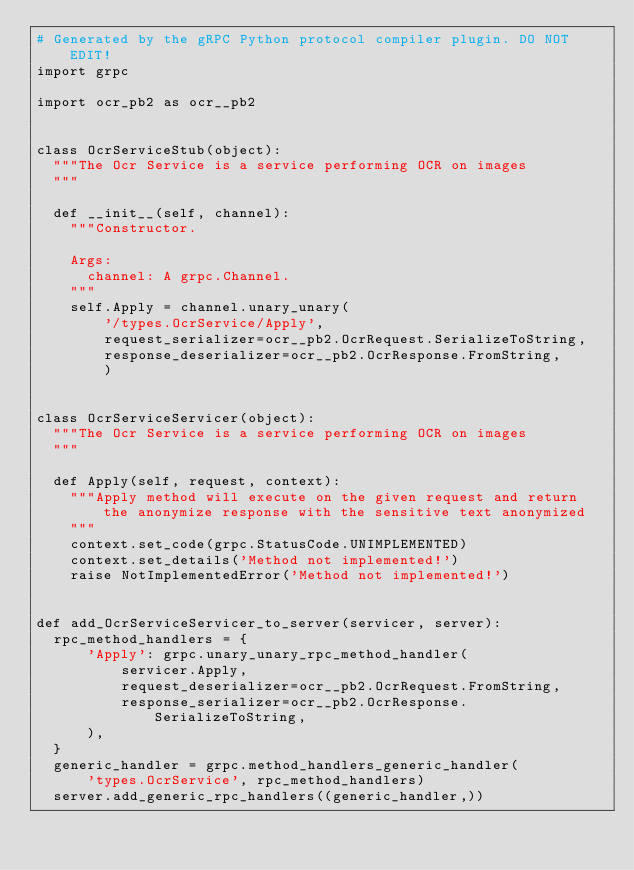Convert code to text. <code><loc_0><loc_0><loc_500><loc_500><_Python_># Generated by the gRPC Python protocol compiler plugin. DO NOT EDIT!
import grpc

import ocr_pb2 as ocr__pb2


class OcrServiceStub(object):
  """The Ocr Service is a service performing OCR on images
  """

  def __init__(self, channel):
    """Constructor.

    Args:
      channel: A grpc.Channel.
    """
    self.Apply = channel.unary_unary(
        '/types.OcrService/Apply',
        request_serializer=ocr__pb2.OcrRequest.SerializeToString,
        response_deserializer=ocr__pb2.OcrResponse.FromString,
        )


class OcrServiceServicer(object):
  """The Ocr Service is a service performing OCR on images
  """

  def Apply(self, request, context):
    """Apply method will execute on the given request and return the anonymize response with the sensitive text anonymized
    """
    context.set_code(grpc.StatusCode.UNIMPLEMENTED)
    context.set_details('Method not implemented!')
    raise NotImplementedError('Method not implemented!')


def add_OcrServiceServicer_to_server(servicer, server):
  rpc_method_handlers = {
      'Apply': grpc.unary_unary_rpc_method_handler(
          servicer.Apply,
          request_deserializer=ocr__pb2.OcrRequest.FromString,
          response_serializer=ocr__pb2.OcrResponse.SerializeToString,
      ),
  }
  generic_handler = grpc.method_handlers_generic_handler(
      'types.OcrService', rpc_method_handlers)
  server.add_generic_rpc_handlers((generic_handler,))
</code> 